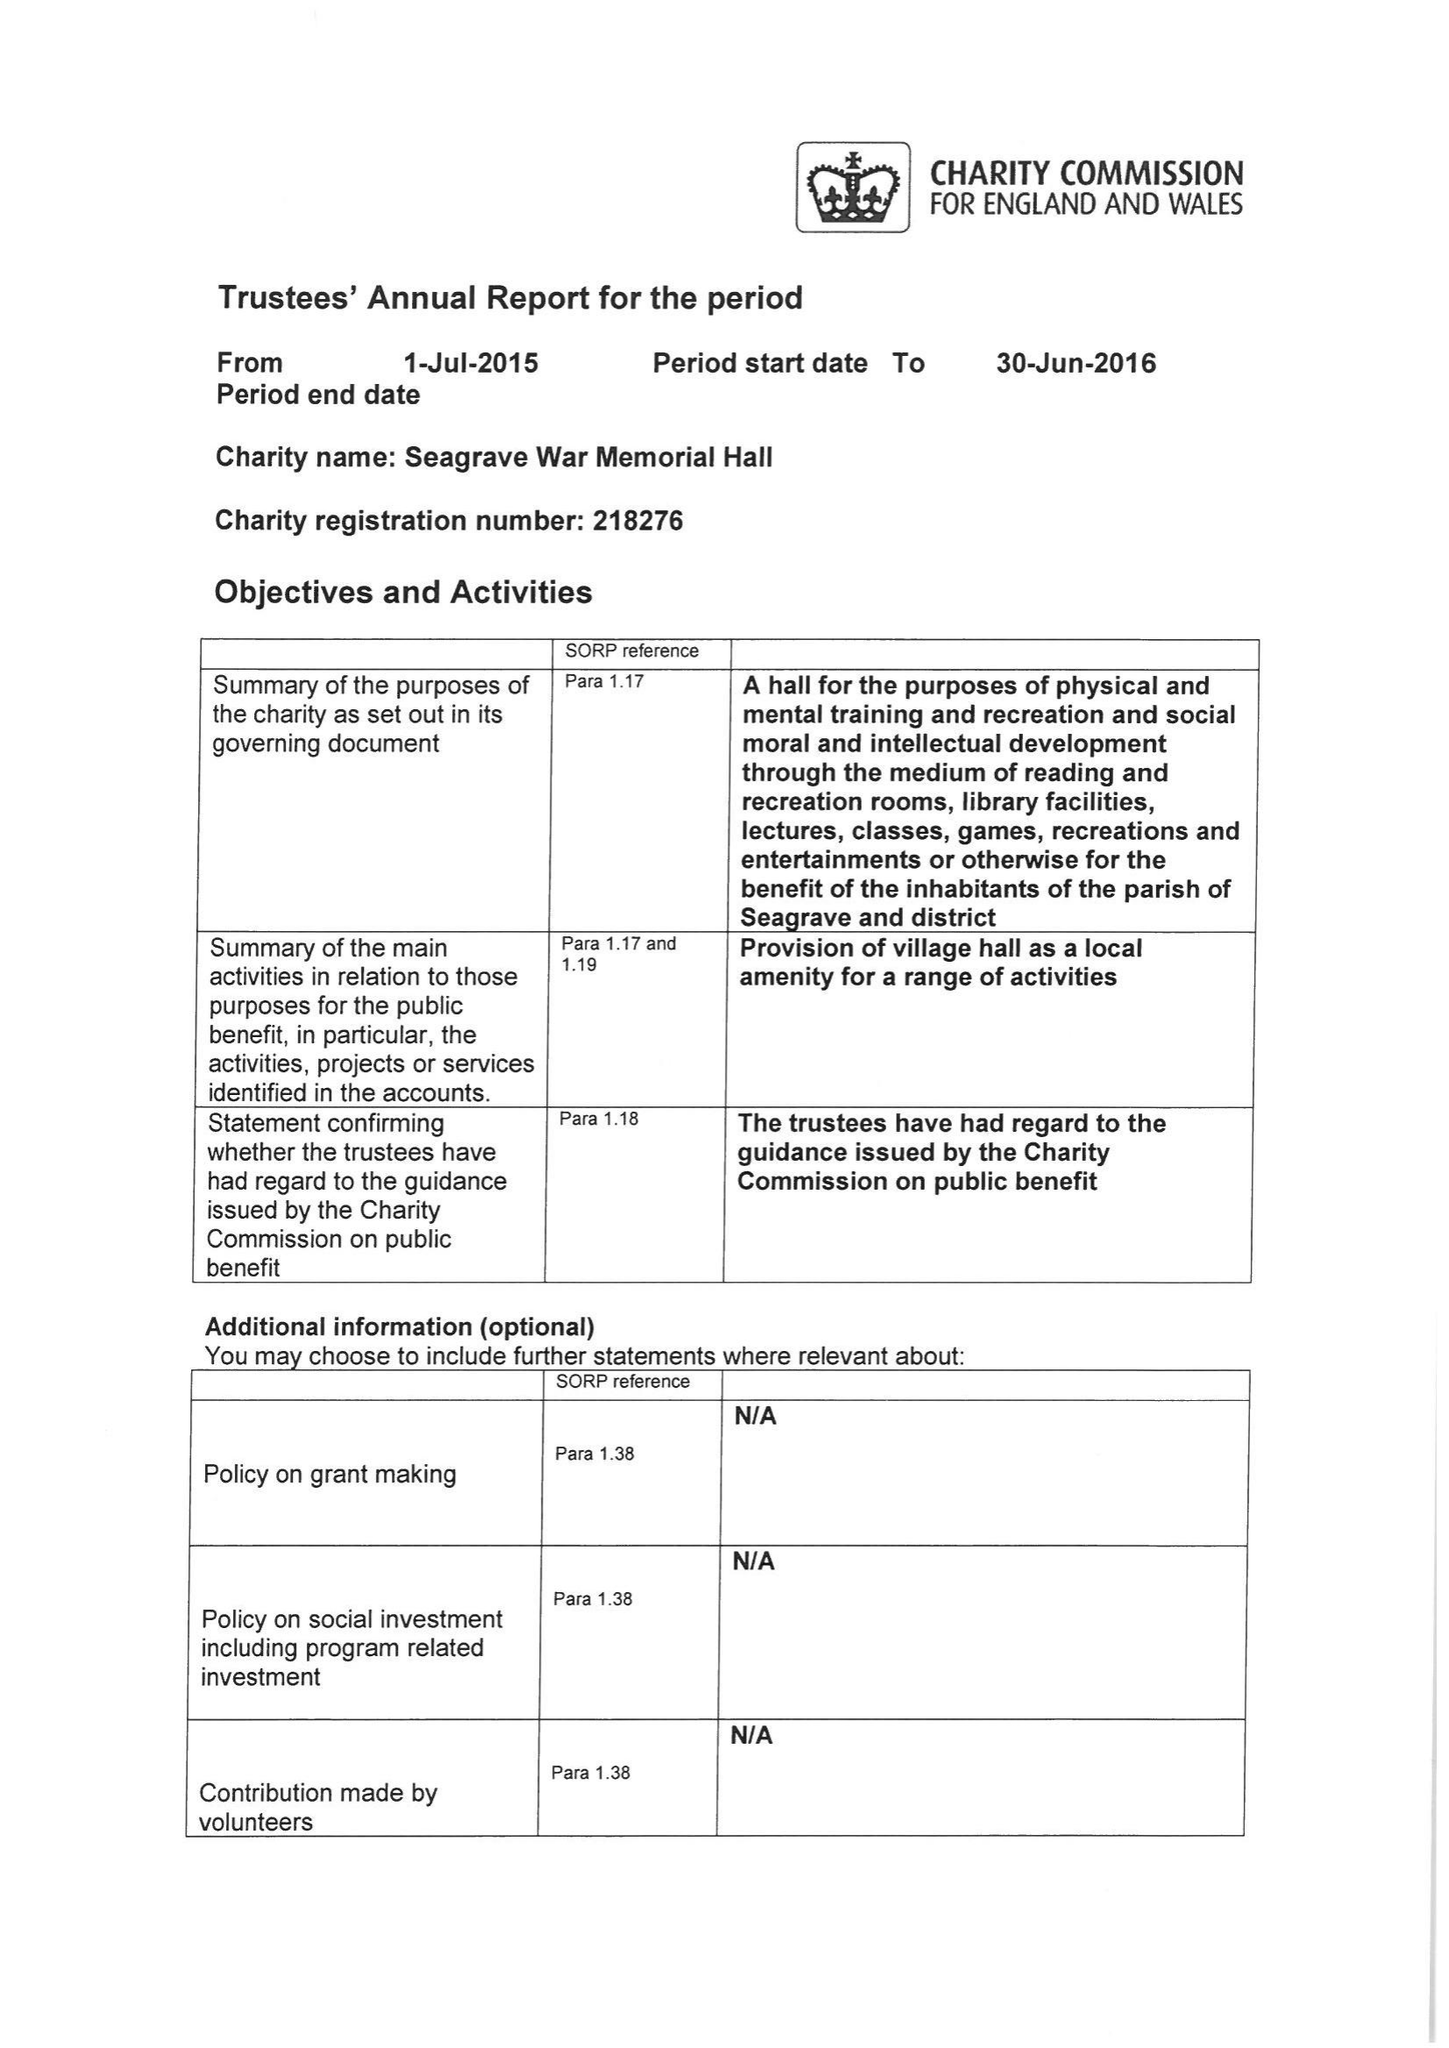What is the value for the spending_annually_in_british_pounds?
Answer the question using a single word or phrase. 34382.94 